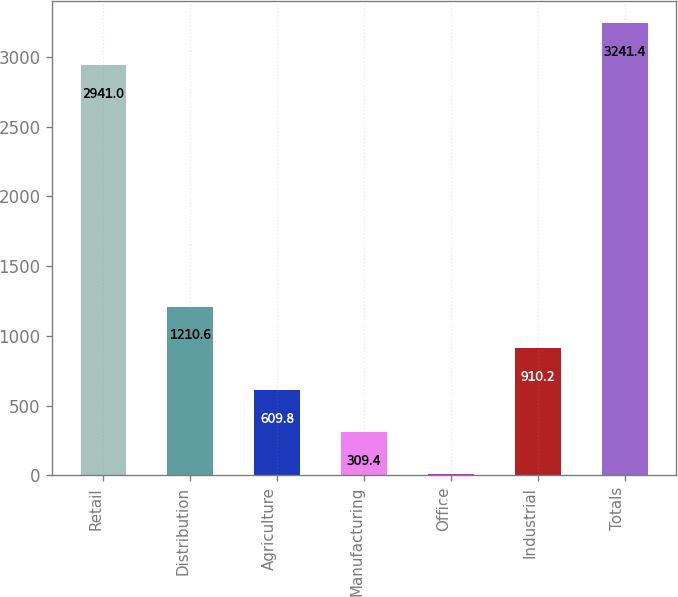Convert chart to OTSL. <chart><loc_0><loc_0><loc_500><loc_500><bar_chart><fcel>Retail<fcel>Distribution<fcel>Agriculture<fcel>Manufacturing<fcel>Office<fcel>Industrial<fcel>Totals<nl><fcel>2941<fcel>1210.6<fcel>609.8<fcel>309.4<fcel>9<fcel>910.2<fcel>3241.4<nl></chart> 